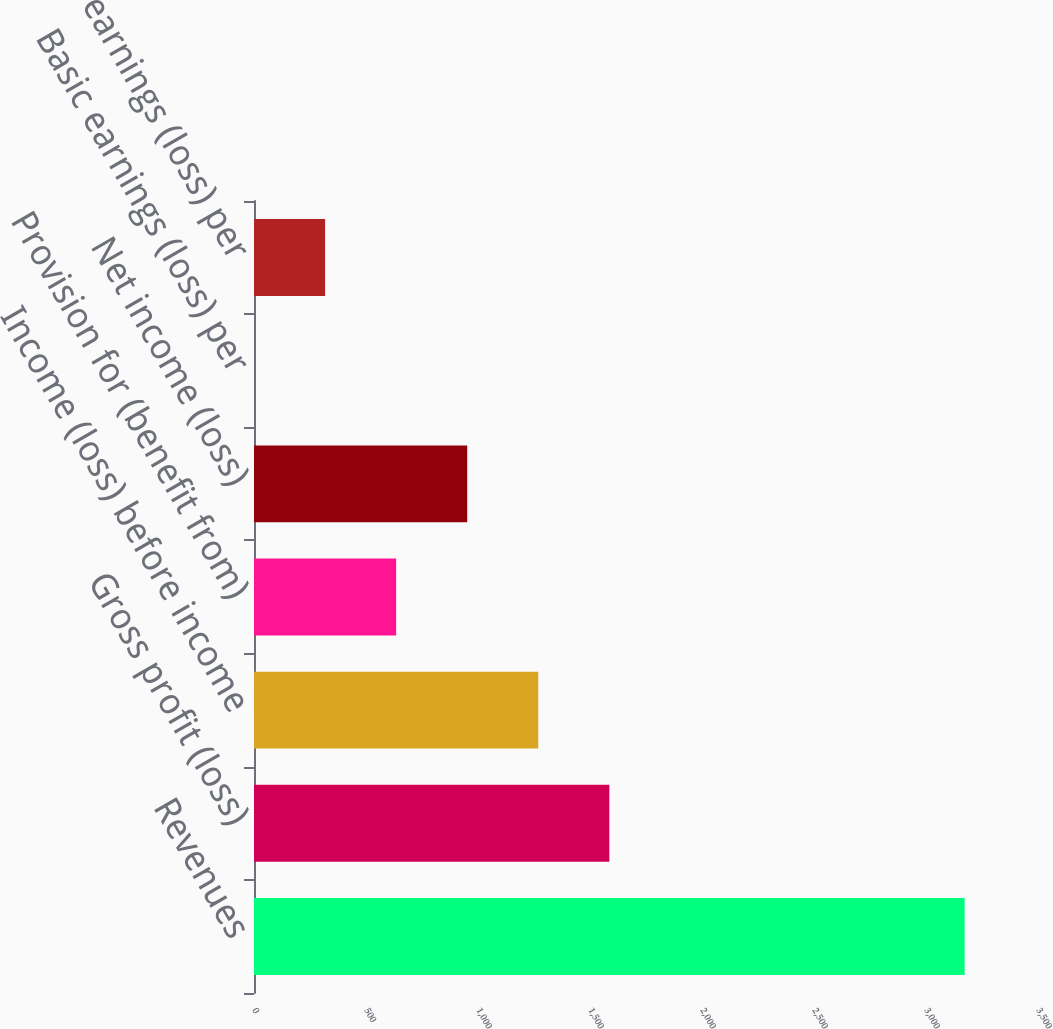<chart> <loc_0><loc_0><loc_500><loc_500><bar_chart><fcel>Revenues<fcel>Gross profit (loss)<fcel>Income (loss) before income<fcel>Provision for (benefit from)<fcel>Net income (loss)<fcel>Basic earnings (loss) per<fcel>Diluted earnings (loss) per<nl><fcel>3172.4<fcel>1586.26<fcel>1269.04<fcel>634.6<fcel>951.82<fcel>0.16<fcel>317.38<nl></chart> 